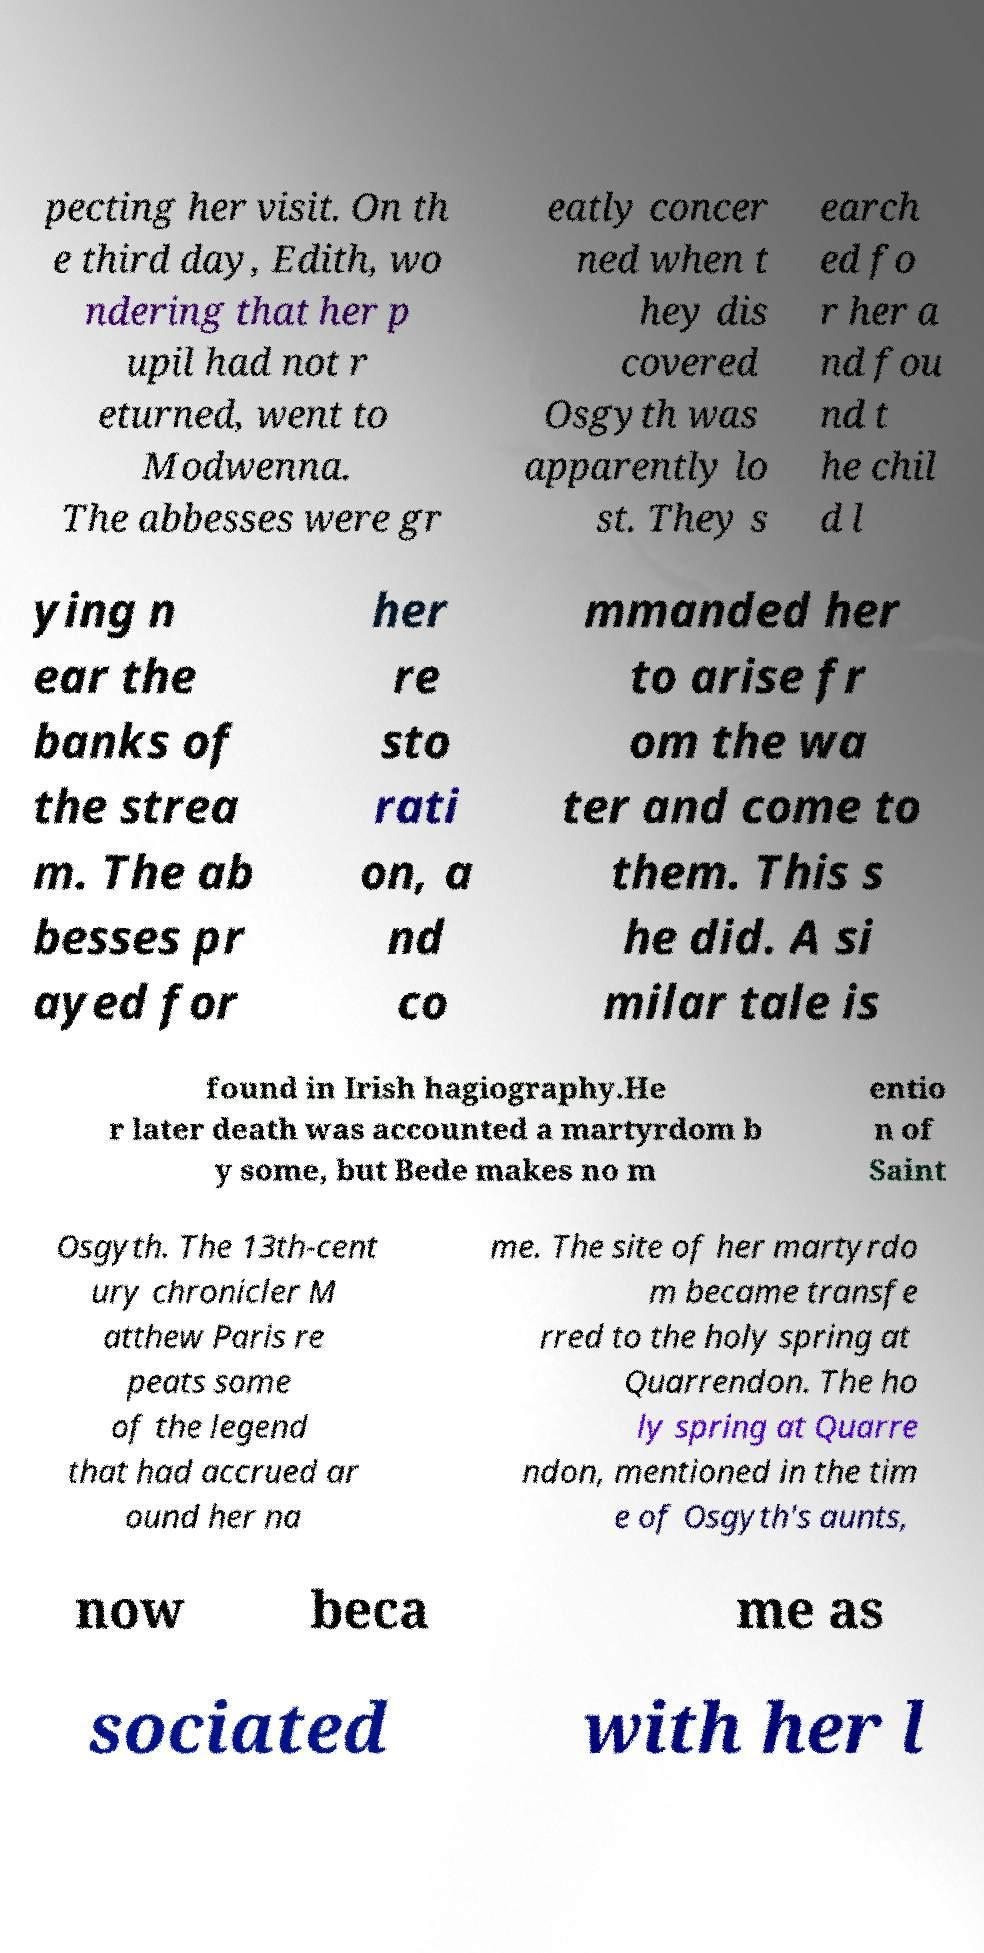I need the written content from this picture converted into text. Can you do that? pecting her visit. On th e third day, Edith, wo ndering that her p upil had not r eturned, went to Modwenna. The abbesses were gr eatly concer ned when t hey dis covered Osgyth was apparently lo st. They s earch ed fo r her a nd fou nd t he chil d l ying n ear the banks of the strea m. The ab besses pr ayed for her re sto rati on, a nd co mmanded her to arise fr om the wa ter and come to them. This s he did. A si milar tale is found in Irish hagiography.He r later death was accounted a martyrdom b y some, but Bede makes no m entio n of Saint Osgyth. The 13th-cent ury chronicler M atthew Paris re peats some of the legend that had accrued ar ound her na me. The site of her martyrdo m became transfe rred to the holy spring at Quarrendon. The ho ly spring at Quarre ndon, mentioned in the tim e of Osgyth's aunts, now beca me as sociated with her l 